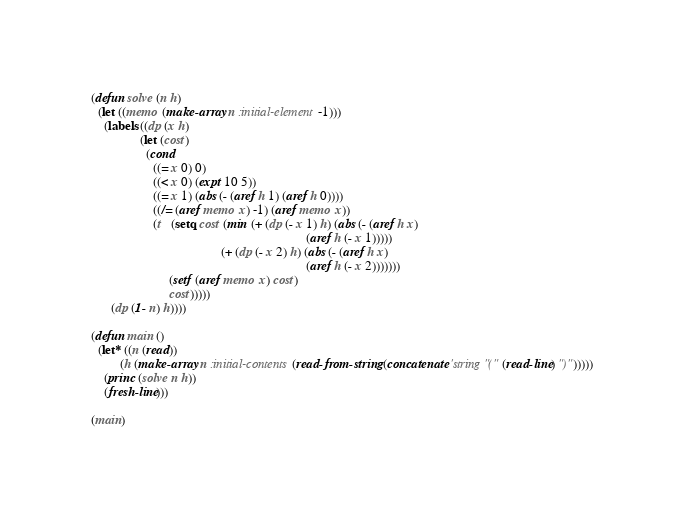<code> <loc_0><loc_0><loc_500><loc_500><_Lisp_>(defun solve (n h)
  (let ((memo (make-array n :initial-element -1)))
    (labels ((dp (x h)
               (let (cost)
                 (cond
                   ((= x 0) 0)
                   ((< x 0) (expt 10 5))
                   ((= x 1) (abs (- (aref h 1) (aref h 0))))
                   ((/= (aref memo x) -1) (aref memo x))
                   (t   (setq cost (min (+ (dp (- x 1) h) (abs (- (aref h x)
                                                                  (aref h (- x 1)))))
                                        (+ (dp (- x 2) h) (abs (- (aref h x)
                                                                  (aref h (- x 2)))))))
                        (setf (aref memo x) cost)
                        cost)))))
      (dp (1- n) h))))

(defun main ()
  (let* ((n (read))
         (h (make-array n :initial-contents (read-from-string (concatenate 'string "(" (read-line) ")")))))
    (princ (solve n h))
    (fresh-line)))

(main)
</code> 